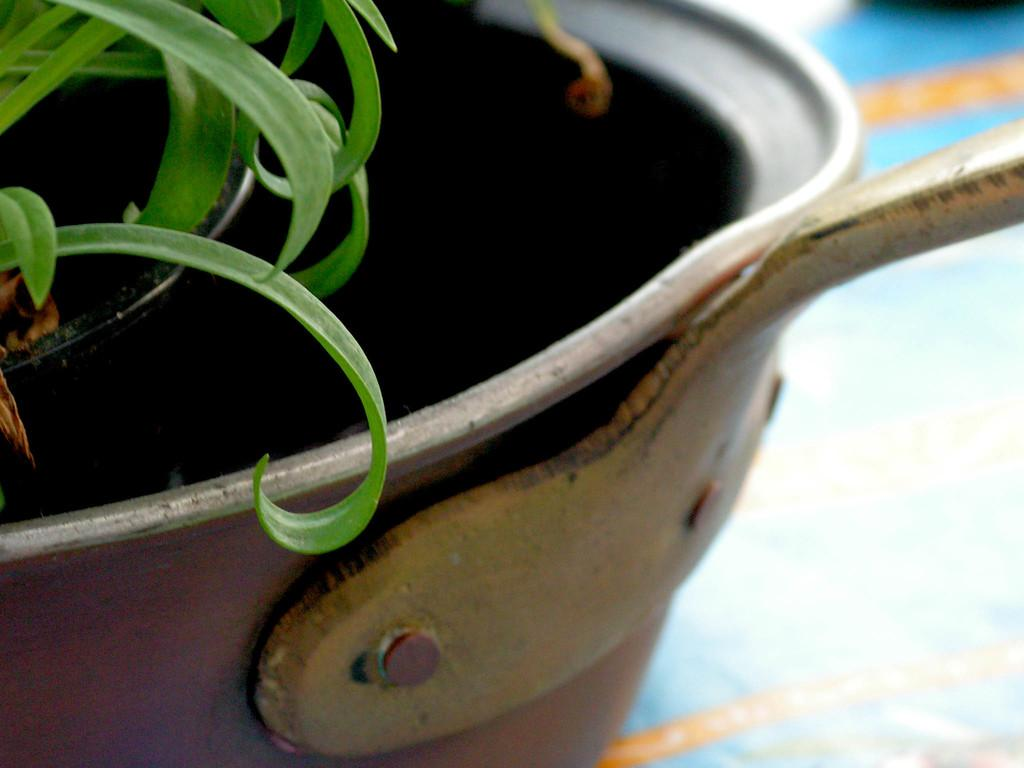What type of plant parts are visible in the image? There are leaves of a plant in the image. Where are the leaves located? The leaves are in a flower pot. What type of property is visible in the image? There is no property visible in the image; it features leaves of a plant in a flower pot. What type of metal is used to make the leaves in the image? The leaves in the image are not made of metal; they are part of a plant. 